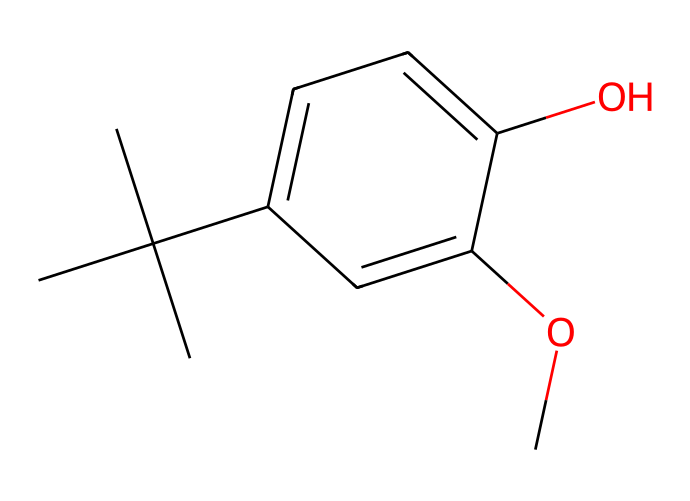What is the molecular formula of butylated hydroxyanisole? To determine the molecular formula, we count the number of each type of atom in the SMILES representation. Looking at the structure, we find 12 carbon atoms, 16 hydrogen atoms, and 3 oxygen atoms. Therefore, the molecular formula is C12H16O3.
Answer: C12H16O3 How many hydroxyl groups are present in BHA? A hydroxyl group consists of an -OH functional group. In the SMILES notation, we can see one hydroxyl group attached to the aromatic ring indicated by the O atom connected to a carbon. Therefore, there is one hydroxyl group.
Answer: 1 What type of chemical is butylated hydroxyanisole classified as? BHA is classified primarily as an antioxidant due to its ability to prevent oxidative damage in food and cosmetics, indicated by the presence of the hydroxyl groups and their positioning in the structure.
Answer: antioxidant What is the significance of the methoxy group in the structure? The methoxy group (-OCH3) enhances the molecule's antioxidant properties, allowing it to interact effectively with radicals. In this structure, the methoxy group is located on the aromatic ring, indicating its role in stabilizing the molecule and improving its functionality.
Answer: enhances stability What is the maximum number of hydrogen atoms attached to the carbon skeleton in BHA? Each carbon in a saturated hydrocarbon can have up to four bonds. In the structure of BHA, we can observe that the saturated carbon atoms fulfill their tetravalent requirement with hydrogen atoms. After counting, we find there are indeed 16 hydrogen atoms in total. Hence, the maximum number is 16.
Answer: 16 